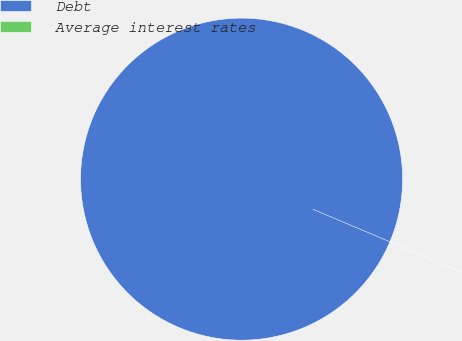Convert chart to OTSL. <chart><loc_0><loc_0><loc_500><loc_500><pie_chart><fcel>Debt<fcel>Average interest rates<nl><fcel>100.0%<fcel>0.0%<nl></chart> 